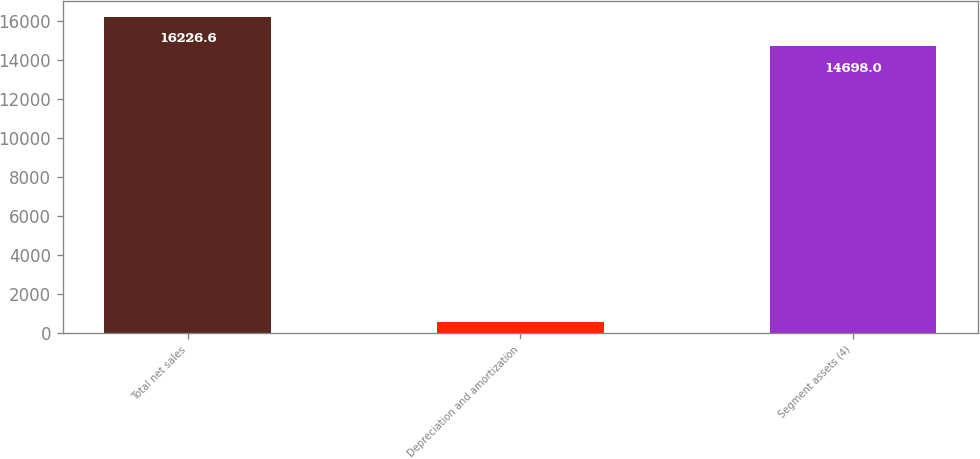Convert chart to OTSL. <chart><loc_0><loc_0><loc_500><loc_500><bar_chart><fcel>Total net sales<fcel>Depreciation and amortization<fcel>Segment assets (4)<nl><fcel>16226.6<fcel>563<fcel>14698<nl></chart> 